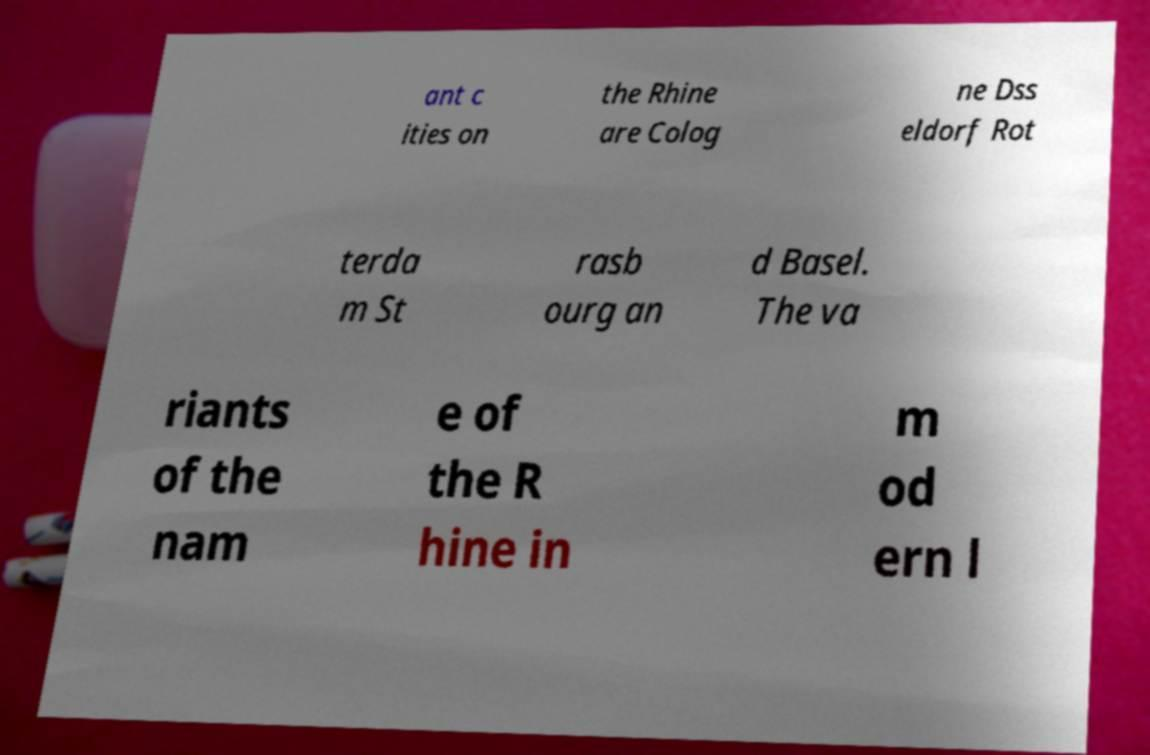Please read and relay the text visible in this image. What does it say? ant c ities on the Rhine are Colog ne Dss eldorf Rot terda m St rasb ourg an d Basel. The va riants of the nam e of the R hine in m od ern l 